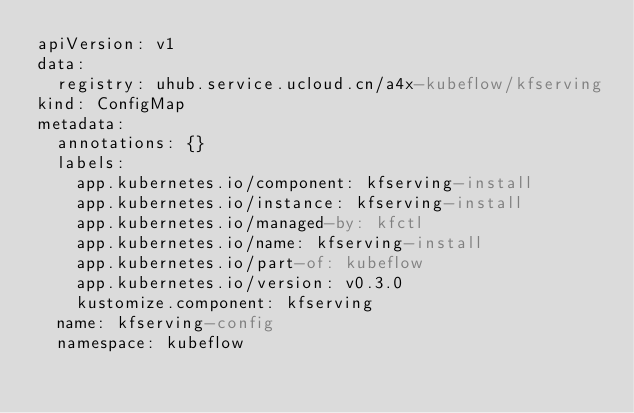Convert code to text. <code><loc_0><loc_0><loc_500><loc_500><_YAML_>apiVersion: v1
data:
  registry: uhub.service.ucloud.cn/a4x-kubeflow/kfserving
kind: ConfigMap
metadata:
  annotations: {}
  labels:
    app.kubernetes.io/component: kfserving-install
    app.kubernetes.io/instance: kfserving-install
    app.kubernetes.io/managed-by: kfctl
    app.kubernetes.io/name: kfserving-install
    app.kubernetes.io/part-of: kubeflow
    app.kubernetes.io/version: v0.3.0
    kustomize.component: kfserving
  name: kfserving-config
  namespace: kubeflow
</code> 